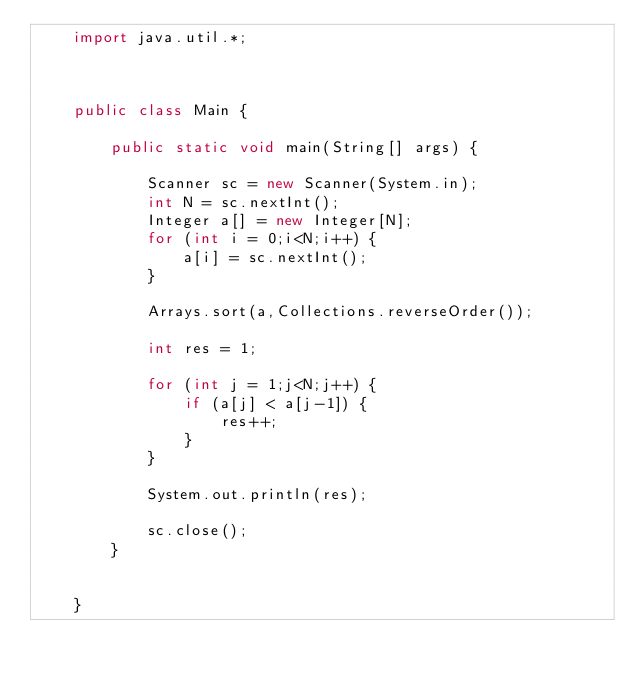<code> <loc_0><loc_0><loc_500><loc_500><_Java_>	import java.util.*;
	
	
	
	public class Main {
	
		public static void main(String[] args) {
		
			Scanner sc = new Scanner(System.in);
			int N = sc.nextInt();
			Integer a[] = new Integer[N];
			for (int i = 0;i<N;i++) {
				a[i] = sc.nextInt();
			}
			
			Arrays.sort(a,Collections.reverseOrder());
			
			int res = 1;
			
			for (int j = 1;j<N;j++) {
				if (a[j] < a[j-1]) {
					res++;
				}
			}
			
			System.out.println(res);
			
			sc.close();
		}
		
		
	}</code> 